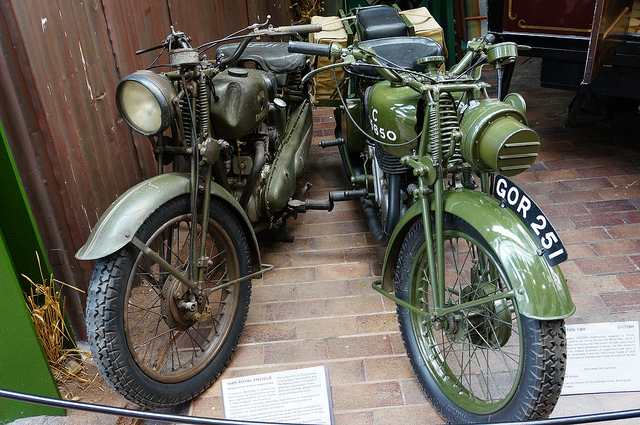Please transcribe the text in this image. C GOR 251 B50 